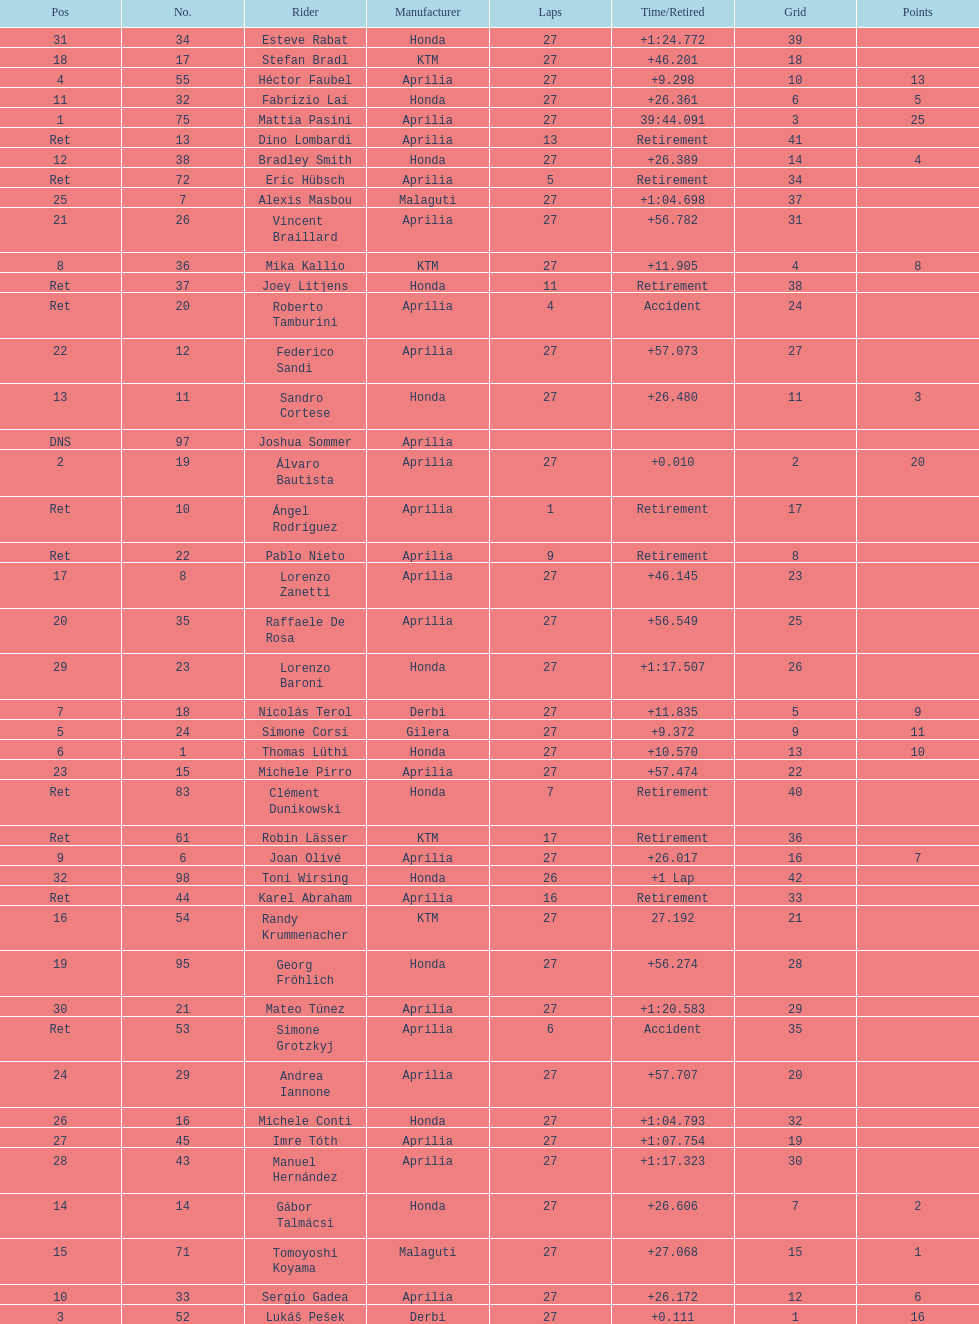Who placed higher, bradl or gadea? Sergio Gadea. 